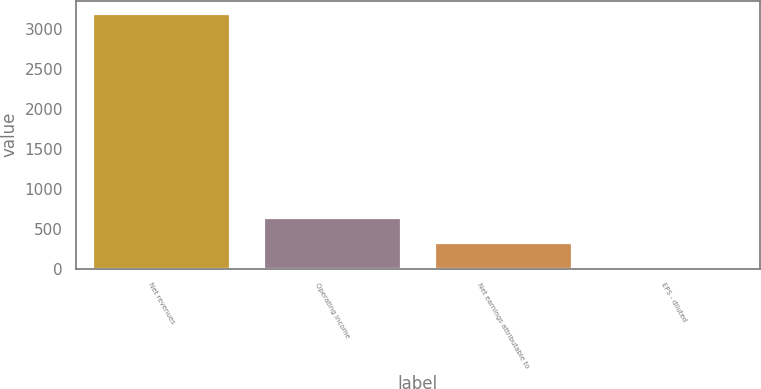Convert chart to OTSL. <chart><loc_0><loc_0><loc_500><loc_500><bar_chart><fcel>Net revenues<fcel>Operating income<fcel>Net earnings attributable to<fcel>EPS - diluted<nl><fcel>3195.9<fcel>639.5<fcel>319.95<fcel>0.4<nl></chart> 